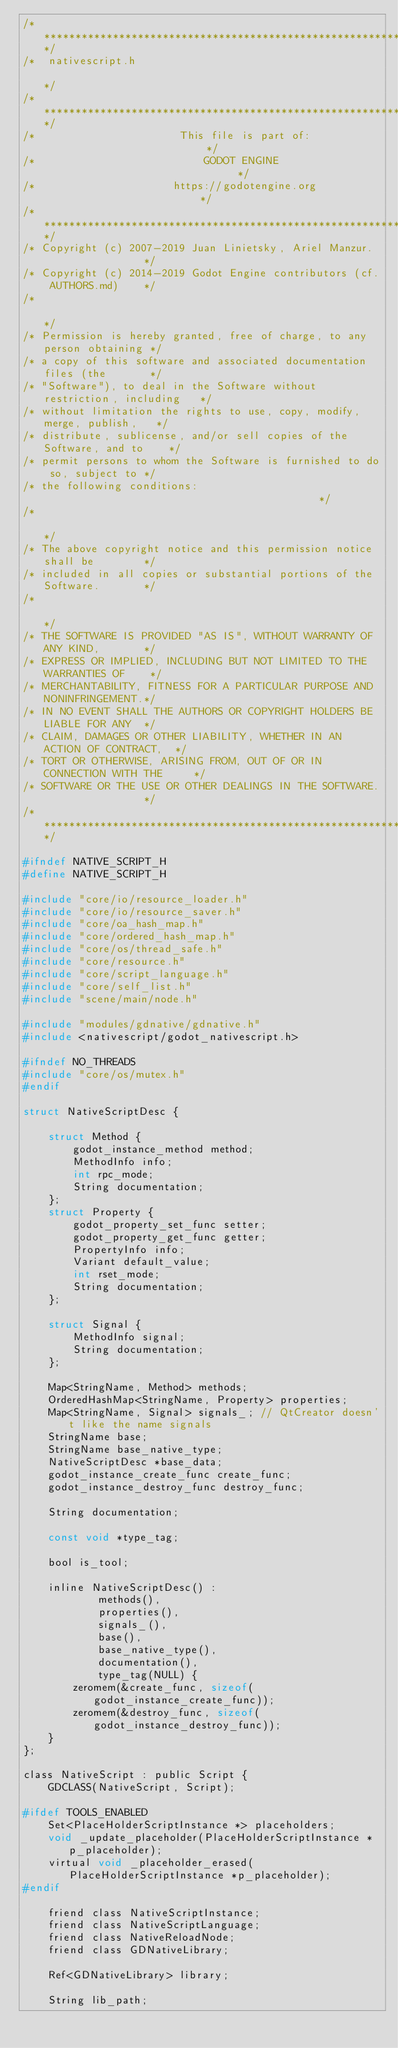Convert code to text. <code><loc_0><loc_0><loc_500><loc_500><_C_>/*************************************************************************/
/*  nativescript.h                                                       */
/*************************************************************************/
/*                       This file is part of:                           */
/*                           GODOT ENGINE                                */
/*                      https://godotengine.org                          */
/*************************************************************************/
/* Copyright (c) 2007-2019 Juan Linietsky, Ariel Manzur.                 */
/* Copyright (c) 2014-2019 Godot Engine contributors (cf. AUTHORS.md)    */
/*                                                                       */
/* Permission is hereby granted, free of charge, to any person obtaining */
/* a copy of this software and associated documentation files (the       */
/* "Software"), to deal in the Software without restriction, including   */
/* without limitation the rights to use, copy, modify, merge, publish,   */
/* distribute, sublicense, and/or sell copies of the Software, and to    */
/* permit persons to whom the Software is furnished to do so, subject to */
/* the following conditions:                                             */
/*                                                                       */
/* The above copyright notice and this permission notice shall be        */
/* included in all copies or substantial portions of the Software.       */
/*                                                                       */
/* THE SOFTWARE IS PROVIDED "AS IS", WITHOUT WARRANTY OF ANY KIND,       */
/* EXPRESS OR IMPLIED, INCLUDING BUT NOT LIMITED TO THE WARRANTIES OF    */
/* MERCHANTABILITY, FITNESS FOR A PARTICULAR PURPOSE AND NONINFRINGEMENT.*/
/* IN NO EVENT SHALL THE AUTHORS OR COPYRIGHT HOLDERS BE LIABLE FOR ANY  */
/* CLAIM, DAMAGES OR OTHER LIABILITY, WHETHER IN AN ACTION OF CONTRACT,  */
/* TORT OR OTHERWISE, ARISING FROM, OUT OF OR IN CONNECTION WITH THE     */
/* SOFTWARE OR THE USE OR OTHER DEALINGS IN THE SOFTWARE.                */
/*************************************************************************/

#ifndef NATIVE_SCRIPT_H
#define NATIVE_SCRIPT_H

#include "core/io/resource_loader.h"
#include "core/io/resource_saver.h"
#include "core/oa_hash_map.h"
#include "core/ordered_hash_map.h"
#include "core/os/thread_safe.h"
#include "core/resource.h"
#include "core/script_language.h"
#include "core/self_list.h"
#include "scene/main/node.h"

#include "modules/gdnative/gdnative.h"
#include <nativescript/godot_nativescript.h>

#ifndef NO_THREADS
#include "core/os/mutex.h"
#endif

struct NativeScriptDesc {

	struct Method {
		godot_instance_method method;
		MethodInfo info;
		int rpc_mode;
		String documentation;
	};
	struct Property {
		godot_property_set_func setter;
		godot_property_get_func getter;
		PropertyInfo info;
		Variant default_value;
		int rset_mode;
		String documentation;
	};

	struct Signal {
		MethodInfo signal;
		String documentation;
	};

	Map<StringName, Method> methods;
	OrderedHashMap<StringName, Property> properties;
	Map<StringName, Signal> signals_; // QtCreator doesn't like the name signals
	StringName base;
	StringName base_native_type;
	NativeScriptDesc *base_data;
	godot_instance_create_func create_func;
	godot_instance_destroy_func destroy_func;

	String documentation;

	const void *type_tag;

	bool is_tool;

	inline NativeScriptDesc() :
			methods(),
			properties(),
			signals_(),
			base(),
			base_native_type(),
			documentation(),
			type_tag(NULL) {
		zeromem(&create_func, sizeof(godot_instance_create_func));
		zeromem(&destroy_func, sizeof(godot_instance_destroy_func));
	}
};

class NativeScript : public Script {
	GDCLASS(NativeScript, Script);

#ifdef TOOLS_ENABLED
	Set<PlaceHolderScriptInstance *> placeholders;
	void _update_placeholder(PlaceHolderScriptInstance *p_placeholder);
	virtual void _placeholder_erased(PlaceHolderScriptInstance *p_placeholder);
#endif

	friend class NativeScriptInstance;
	friend class NativeScriptLanguage;
	friend class NativeReloadNode;
	friend class GDNativeLibrary;

	Ref<GDNativeLibrary> library;

	String lib_path;
</code> 